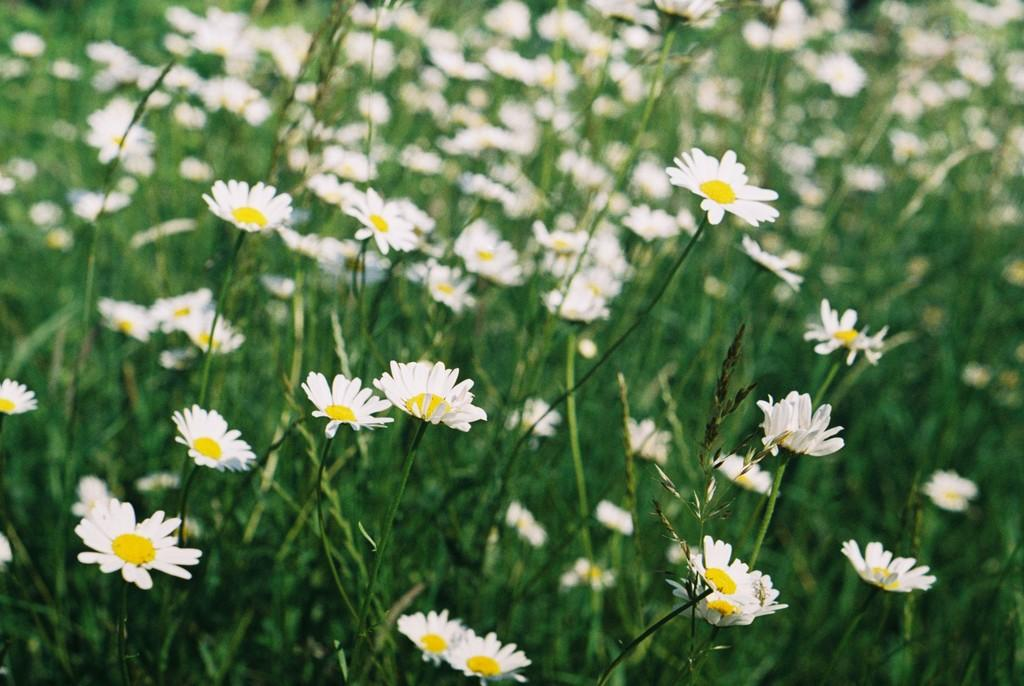What color are the flowers on the plants in the image? The flowers on the plants in the image are white. What type of current can be seen flowing through the car in the image? There is no car present in the image, and therefore no current can be seen flowing through it. 